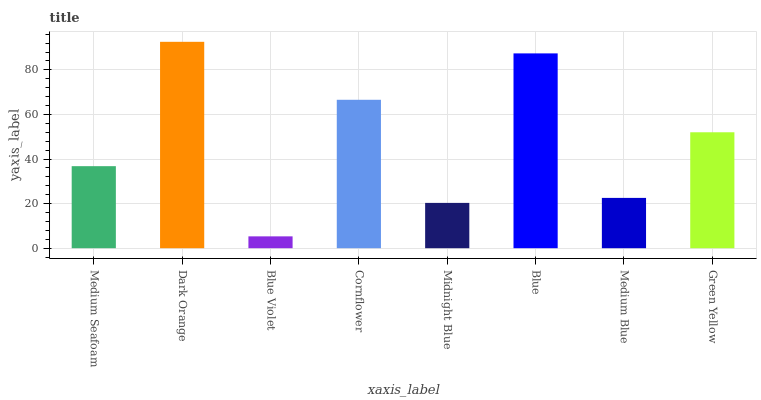Is Dark Orange the minimum?
Answer yes or no. No. Is Blue Violet the maximum?
Answer yes or no. No. Is Dark Orange greater than Blue Violet?
Answer yes or no. Yes. Is Blue Violet less than Dark Orange?
Answer yes or no. Yes. Is Blue Violet greater than Dark Orange?
Answer yes or no. No. Is Dark Orange less than Blue Violet?
Answer yes or no. No. Is Green Yellow the high median?
Answer yes or no. Yes. Is Medium Seafoam the low median?
Answer yes or no. Yes. Is Blue Violet the high median?
Answer yes or no. No. Is Blue the low median?
Answer yes or no. No. 